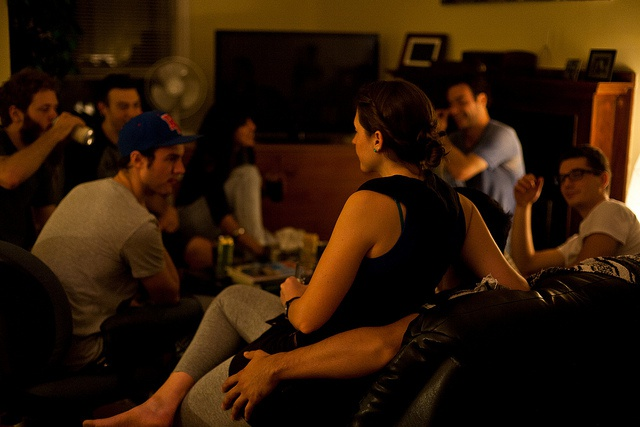Describe the objects in this image and their specific colors. I can see people in maroon, black, and brown tones, couch in maroon, black, and olive tones, people in maroon, black, and olive tones, tv in maroon, black, and red tones, and chair in black and maroon tones in this image. 